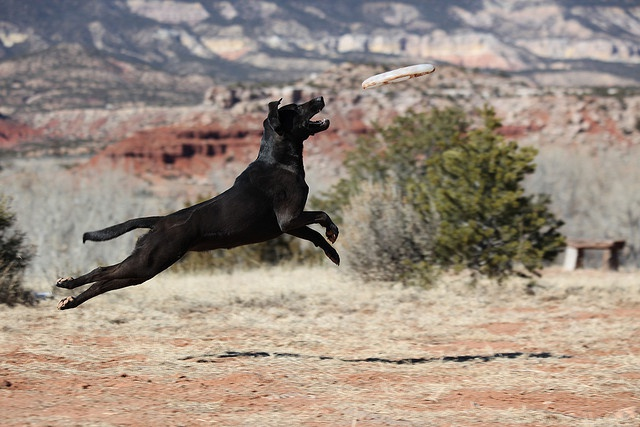Describe the objects in this image and their specific colors. I can see dog in gray, black, and darkgray tones and frisbee in gray, lightgray, darkgray, and tan tones in this image. 